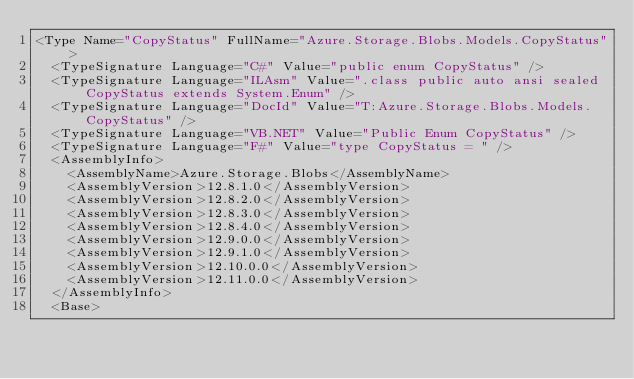<code> <loc_0><loc_0><loc_500><loc_500><_XML_><Type Name="CopyStatus" FullName="Azure.Storage.Blobs.Models.CopyStatus">
  <TypeSignature Language="C#" Value="public enum CopyStatus" />
  <TypeSignature Language="ILAsm" Value=".class public auto ansi sealed CopyStatus extends System.Enum" />
  <TypeSignature Language="DocId" Value="T:Azure.Storage.Blobs.Models.CopyStatus" />
  <TypeSignature Language="VB.NET" Value="Public Enum CopyStatus" />
  <TypeSignature Language="F#" Value="type CopyStatus = " />
  <AssemblyInfo>
    <AssemblyName>Azure.Storage.Blobs</AssemblyName>
    <AssemblyVersion>12.8.1.0</AssemblyVersion>
    <AssemblyVersion>12.8.2.0</AssemblyVersion>
    <AssemblyVersion>12.8.3.0</AssemblyVersion>
    <AssemblyVersion>12.8.4.0</AssemblyVersion>
    <AssemblyVersion>12.9.0.0</AssemblyVersion>
    <AssemblyVersion>12.9.1.0</AssemblyVersion>
    <AssemblyVersion>12.10.0.0</AssemblyVersion>
    <AssemblyVersion>12.11.0.0</AssemblyVersion>
  </AssemblyInfo>
  <Base></code> 